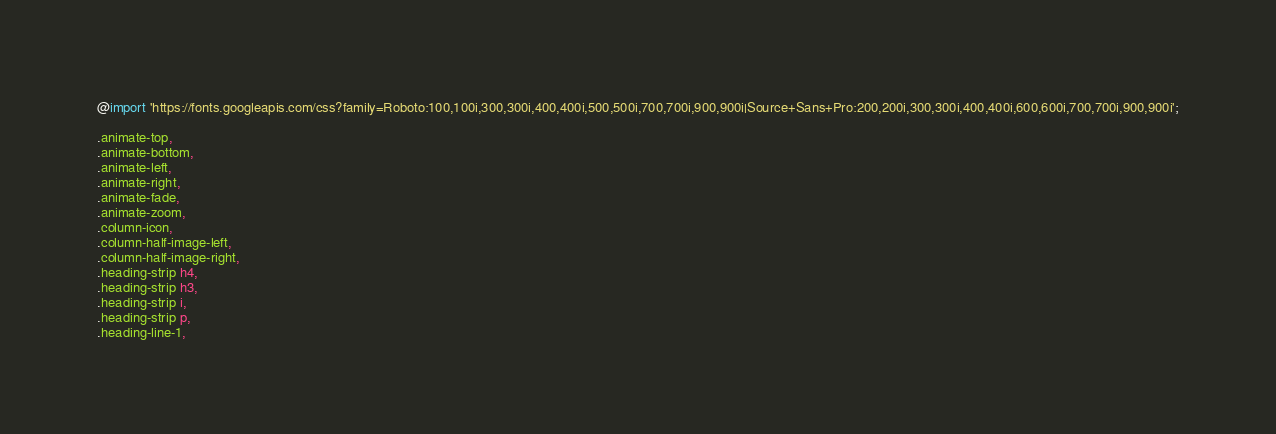Convert code to text. <code><loc_0><loc_0><loc_500><loc_500><_CSS_>@import 'https://fonts.googleapis.com/css?family=Roboto:100,100i,300,300i,400,400i,500,500i,700,700i,900,900i|Source+Sans+Pro:200,200i,300,300i,400,400i,600,600i,700,700i,900,900i';

.animate-top,
.animate-bottom,
.animate-left,
.animate-right,
.animate-fade,
.animate-zoom,
.column-icon,
.column-half-image-left,
.column-half-image-right,
.heading-strip h4,
.heading-strip h3,
.heading-strip i,
.heading-strip p,
.heading-line-1,</code> 